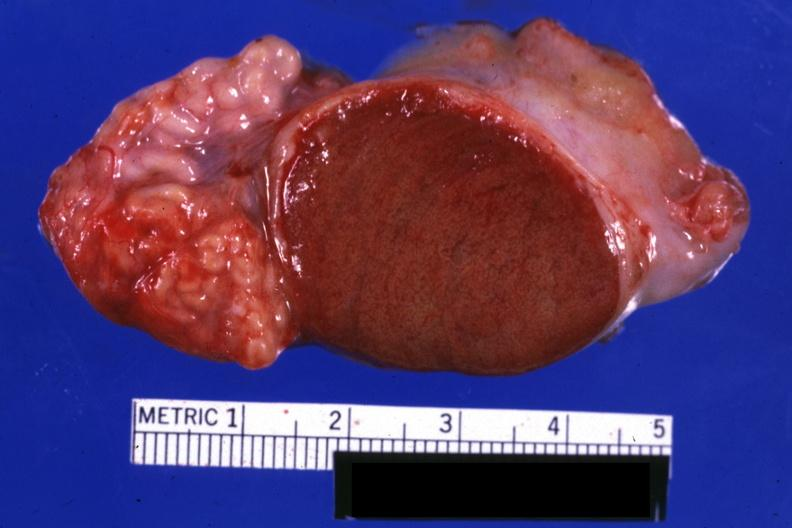what is excellent close-up view sliced?
Answer the question using a single word or phrase. View sliced open testicle with intact epididymis 